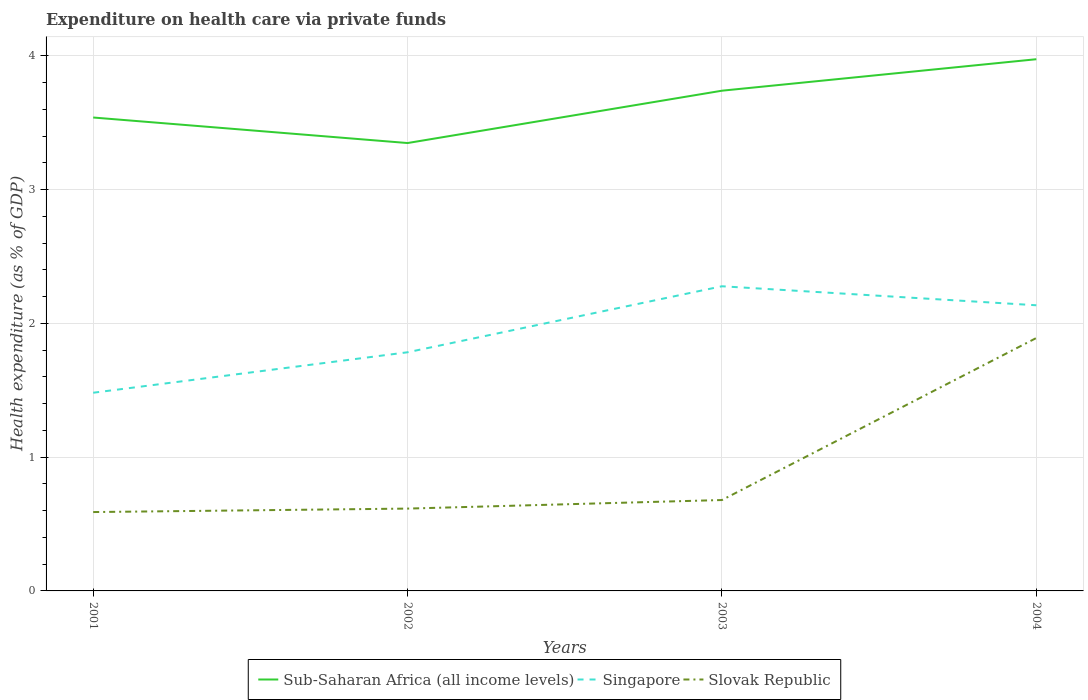How many different coloured lines are there?
Offer a very short reply. 3. Is the number of lines equal to the number of legend labels?
Offer a very short reply. Yes. Across all years, what is the maximum expenditure made on health care in Singapore?
Your answer should be very brief. 1.48. What is the total expenditure made on health care in Slovak Republic in the graph?
Your answer should be compact. -0.03. What is the difference between the highest and the second highest expenditure made on health care in Sub-Saharan Africa (all income levels)?
Provide a succinct answer. 0.63. How many lines are there?
Make the answer very short. 3. How many years are there in the graph?
Give a very brief answer. 4. What is the difference between two consecutive major ticks on the Y-axis?
Make the answer very short. 1. Are the values on the major ticks of Y-axis written in scientific E-notation?
Your response must be concise. No. Does the graph contain any zero values?
Your response must be concise. No. Does the graph contain grids?
Ensure brevity in your answer.  Yes. Where does the legend appear in the graph?
Your answer should be very brief. Bottom center. How are the legend labels stacked?
Ensure brevity in your answer.  Horizontal. What is the title of the graph?
Provide a short and direct response. Expenditure on health care via private funds. Does "Dominican Republic" appear as one of the legend labels in the graph?
Your answer should be very brief. No. What is the label or title of the Y-axis?
Provide a short and direct response. Health expenditure (as % of GDP). What is the Health expenditure (as % of GDP) of Sub-Saharan Africa (all income levels) in 2001?
Offer a terse response. 3.54. What is the Health expenditure (as % of GDP) in Singapore in 2001?
Give a very brief answer. 1.48. What is the Health expenditure (as % of GDP) of Slovak Republic in 2001?
Your answer should be compact. 0.59. What is the Health expenditure (as % of GDP) in Sub-Saharan Africa (all income levels) in 2002?
Offer a very short reply. 3.35. What is the Health expenditure (as % of GDP) of Singapore in 2002?
Ensure brevity in your answer.  1.78. What is the Health expenditure (as % of GDP) in Slovak Republic in 2002?
Give a very brief answer. 0.62. What is the Health expenditure (as % of GDP) in Sub-Saharan Africa (all income levels) in 2003?
Your response must be concise. 3.74. What is the Health expenditure (as % of GDP) of Singapore in 2003?
Your answer should be very brief. 2.28. What is the Health expenditure (as % of GDP) of Slovak Republic in 2003?
Keep it short and to the point. 0.68. What is the Health expenditure (as % of GDP) in Sub-Saharan Africa (all income levels) in 2004?
Give a very brief answer. 3.98. What is the Health expenditure (as % of GDP) in Singapore in 2004?
Your answer should be very brief. 2.14. What is the Health expenditure (as % of GDP) in Slovak Republic in 2004?
Make the answer very short. 1.89. Across all years, what is the maximum Health expenditure (as % of GDP) in Sub-Saharan Africa (all income levels)?
Offer a very short reply. 3.98. Across all years, what is the maximum Health expenditure (as % of GDP) of Singapore?
Provide a succinct answer. 2.28. Across all years, what is the maximum Health expenditure (as % of GDP) of Slovak Republic?
Make the answer very short. 1.89. Across all years, what is the minimum Health expenditure (as % of GDP) of Sub-Saharan Africa (all income levels)?
Your answer should be very brief. 3.35. Across all years, what is the minimum Health expenditure (as % of GDP) of Singapore?
Your response must be concise. 1.48. Across all years, what is the minimum Health expenditure (as % of GDP) of Slovak Republic?
Provide a short and direct response. 0.59. What is the total Health expenditure (as % of GDP) of Sub-Saharan Africa (all income levels) in the graph?
Ensure brevity in your answer.  14.6. What is the total Health expenditure (as % of GDP) of Singapore in the graph?
Offer a terse response. 7.68. What is the total Health expenditure (as % of GDP) in Slovak Republic in the graph?
Your answer should be very brief. 3.78. What is the difference between the Health expenditure (as % of GDP) in Sub-Saharan Africa (all income levels) in 2001 and that in 2002?
Make the answer very short. 0.19. What is the difference between the Health expenditure (as % of GDP) in Singapore in 2001 and that in 2002?
Make the answer very short. -0.3. What is the difference between the Health expenditure (as % of GDP) in Slovak Republic in 2001 and that in 2002?
Offer a very short reply. -0.03. What is the difference between the Health expenditure (as % of GDP) in Sub-Saharan Africa (all income levels) in 2001 and that in 2003?
Make the answer very short. -0.2. What is the difference between the Health expenditure (as % of GDP) of Singapore in 2001 and that in 2003?
Ensure brevity in your answer.  -0.8. What is the difference between the Health expenditure (as % of GDP) of Slovak Republic in 2001 and that in 2003?
Your answer should be very brief. -0.09. What is the difference between the Health expenditure (as % of GDP) of Sub-Saharan Africa (all income levels) in 2001 and that in 2004?
Your answer should be very brief. -0.44. What is the difference between the Health expenditure (as % of GDP) of Singapore in 2001 and that in 2004?
Provide a short and direct response. -0.65. What is the difference between the Health expenditure (as % of GDP) in Slovak Republic in 2001 and that in 2004?
Your response must be concise. -1.3. What is the difference between the Health expenditure (as % of GDP) of Sub-Saharan Africa (all income levels) in 2002 and that in 2003?
Keep it short and to the point. -0.39. What is the difference between the Health expenditure (as % of GDP) of Singapore in 2002 and that in 2003?
Provide a short and direct response. -0.49. What is the difference between the Health expenditure (as % of GDP) in Slovak Republic in 2002 and that in 2003?
Your answer should be very brief. -0.06. What is the difference between the Health expenditure (as % of GDP) in Sub-Saharan Africa (all income levels) in 2002 and that in 2004?
Ensure brevity in your answer.  -0.63. What is the difference between the Health expenditure (as % of GDP) in Singapore in 2002 and that in 2004?
Give a very brief answer. -0.35. What is the difference between the Health expenditure (as % of GDP) in Slovak Republic in 2002 and that in 2004?
Provide a succinct answer. -1.28. What is the difference between the Health expenditure (as % of GDP) of Sub-Saharan Africa (all income levels) in 2003 and that in 2004?
Offer a terse response. -0.24. What is the difference between the Health expenditure (as % of GDP) of Singapore in 2003 and that in 2004?
Give a very brief answer. 0.14. What is the difference between the Health expenditure (as % of GDP) of Slovak Republic in 2003 and that in 2004?
Keep it short and to the point. -1.21. What is the difference between the Health expenditure (as % of GDP) in Sub-Saharan Africa (all income levels) in 2001 and the Health expenditure (as % of GDP) in Singapore in 2002?
Your answer should be compact. 1.76. What is the difference between the Health expenditure (as % of GDP) in Sub-Saharan Africa (all income levels) in 2001 and the Health expenditure (as % of GDP) in Slovak Republic in 2002?
Your answer should be compact. 2.92. What is the difference between the Health expenditure (as % of GDP) of Singapore in 2001 and the Health expenditure (as % of GDP) of Slovak Republic in 2002?
Ensure brevity in your answer.  0.87. What is the difference between the Health expenditure (as % of GDP) of Sub-Saharan Africa (all income levels) in 2001 and the Health expenditure (as % of GDP) of Singapore in 2003?
Make the answer very short. 1.26. What is the difference between the Health expenditure (as % of GDP) of Sub-Saharan Africa (all income levels) in 2001 and the Health expenditure (as % of GDP) of Slovak Republic in 2003?
Your answer should be very brief. 2.86. What is the difference between the Health expenditure (as % of GDP) in Singapore in 2001 and the Health expenditure (as % of GDP) in Slovak Republic in 2003?
Provide a succinct answer. 0.8. What is the difference between the Health expenditure (as % of GDP) of Sub-Saharan Africa (all income levels) in 2001 and the Health expenditure (as % of GDP) of Singapore in 2004?
Make the answer very short. 1.4. What is the difference between the Health expenditure (as % of GDP) of Sub-Saharan Africa (all income levels) in 2001 and the Health expenditure (as % of GDP) of Slovak Republic in 2004?
Your answer should be very brief. 1.65. What is the difference between the Health expenditure (as % of GDP) in Singapore in 2001 and the Health expenditure (as % of GDP) in Slovak Republic in 2004?
Your response must be concise. -0.41. What is the difference between the Health expenditure (as % of GDP) in Sub-Saharan Africa (all income levels) in 2002 and the Health expenditure (as % of GDP) in Singapore in 2003?
Your answer should be very brief. 1.07. What is the difference between the Health expenditure (as % of GDP) of Sub-Saharan Africa (all income levels) in 2002 and the Health expenditure (as % of GDP) of Slovak Republic in 2003?
Keep it short and to the point. 2.67. What is the difference between the Health expenditure (as % of GDP) of Singapore in 2002 and the Health expenditure (as % of GDP) of Slovak Republic in 2003?
Offer a very short reply. 1.1. What is the difference between the Health expenditure (as % of GDP) in Sub-Saharan Africa (all income levels) in 2002 and the Health expenditure (as % of GDP) in Singapore in 2004?
Your answer should be very brief. 1.21. What is the difference between the Health expenditure (as % of GDP) in Sub-Saharan Africa (all income levels) in 2002 and the Health expenditure (as % of GDP) in Slovak Republic in 2004?
Make the answer very short. 1.46. What is the difference between the Health expenditure (as % of GDP) in Singapore in 2002 and the Health expenditure (as % of GDP) in Slovak Republic in 2004?
Make the answer very short. -0.11. What is the difference between the Health expenditure (as % of GDP) in Sub-Saharan Africa (all income levels) in 2003 and the Health expenditure (as % of GDP) in Singapore in 2004?
Ensure brevity in your answer.  1.6. What is the difference between the Health expenditure (as % of GDP) in Sub-Saharan Africa (all income levels) in 2003 and the Health expenditure (as % of GDP) in Slovak Republic in 2004?
Ensure brevity in your answer.  1.85. What is the difference between the Health expenditure (as % of GDP) in Singapore in 2003 and the Health expenditure (as % of GDP) in Slovak Republic in 2004?
Your answer should be compact. 0.39. What is the average Health expenditure (as % of GDP) in Sub-Saharan Africa (all income levels) per year?
Make the answer very short. 3.65. What is the average Health expenditure (as % of GDP) of Singapore per year?
Your answer should be very brief. 1.92. What is the average Health expenditure (as % of GDP) of Slovak Republic per year?
Provide a short and direct response. 0.94. In the year 2001, what is the difference between the Health expenditure (as % of GDP) in Sub-Saharan Africa (all income levels) and Health expenditure (as % of GDP) in Singapore?
Keep it short and to the point. 2.06. In the year 2001, what is the difference between the Health expenditure (as % of GDP) in Sub-Saharan Africa (all income levels) and Health expenditure (as % of GDP) in Slovak Republic?
Keep it short and to the point. 2.95. In the year 2001, what is the difference between the Health expenditure (as % of GDP) in Singapore and Health expenditure (as % of GDP) in Slovak Republic?
Your answer should be very brief. 0.89. In the year 2002, what is the difference between the Health expenditure (as % of GDP) of Sub-Saharan Africa (all income levels) and Health expenditure (as % of GDP) of Singapore?
Your answer should be very brief. 1.56. In the year 2002, what is the difference between the Health expenditure (as % of GDP) of Sub-Saharan Africa (all income levels) and Health expenditure (as % of GDP) of Slovak Republic?
Offer a terse response. 2.73. In the year 2002, what is the difference between the Health expenditure (as % of GDP) of Singapore and Health expenditure (as % of GDP) of Slovak Republic?
Make the answer very short. 1.17. In the year 2003, what is the difference between the Health expenditure (as % of GDP) of Sub-Saharan Africa (all income levels) and Health expenditure (as % of GDP) of Singapore?
Your answer should be compact. 1.46. In the year 2003, what is the difference between the Health expenditure (as % of GDP) in Sub-Saharan Africa (all income levels) and Health expenditure (as % of GDP) in Slovak Republic?
Your response must be concise. 3.06. In the year 2003, what is the difference between the Health expenditure (as % of GDP) in Singapore and Health expenditure (as % of GDP) in Slovak Republic?
Your answer should be compact. 1.6. In the year 2004, what is the difference between the Health expenditure (as % of GDP) in Sub-Saharan Africa (all income levels) and Health expenditure (as % of GDP) in Singapore?
Make the answer very short. 1.84. In the year 2004, what is the difference between the Health expenditure (as % of GDP) of Sub-Saharan Africa (all income levels) and Health expenditure (as % of GDP) of Slovak Republic?
Keep it short and to the point. 2.08. In the year 2004, what is the difference between the Health expenditure (as % of GDP) of Singapore and Health expenditure (as % of GDP) of Slovak Republic?
Offer a very short reply. 0.24. What is the ratio of the Health expenditure (as % of GDP) in Sub-Saharan Africa (all income levels) in 2001 to that in 2002?
Offer a terse response. 1.06. What is the ratio of the Health expenditure (as % of GDP) of Singapore in 2001 to that in 2002?
Provide a succinct answer. 0.83. What is the ratio of the Health expenditure (as % of GDP) in Slovak Republic in 2001 to that in 2002?
Keep it short and to the point. 0.96. What is the ratio of the Health expenditure (as % of GDP) of Sub-Saharan Africa (all income levels) in 2001 to that in 2003?
Keep it short and to the point. 0.95. What is the ratio of the Health expenditure (as % of GDP) of Singapore in 2001 to that in 2003?
Keep it short and to the point. 0.65. What is the ratio of the Health expenditure (as % of GDP) of Slovak Republic in 2001 to that in 2003?
Give a very brief answer. 0.87. What is the ratio of the Health expenditure (as % of GDP) of Sub-Saharan Africa (all income levels) in 2001 to that in 2004?
Provide a short and direct response. 0.89. What is the ratio of the Health expenditure (as % of GDP) of Singapore in 2001 to that in 2004?
Your answer should be compact. 0.69. What is the ratio of the Health expenditure (as % of GDP) in Slovak Republic in 2001 to that in 2004?
Provide a succinct answer. 0.31. What is the ratio of the Health expenditure (as % of GDP) of Sub-Saharan Africa (all income levels) in 2002 to that in 2003?
Keep it short and to the point. 0.9. What is the ratio of the Health expenditure (as % of GDP) of Singapore in 2002 to that in 2003?
Your response must be concise. 0.78. What is the ratio of the Health expenditure (as % of GDP) in Slovak Republic in 2002 to that in 2003?
Provide a short and direct response. 0.91. What is the ratio of the Health expenditure (as % of GDP) of Sub-Saharan Africa (all income levels) in 2002 to that in 2004?
Offer a very short reply. 0.84. What is the ratio of the Health expenditure (as % of GDP) of Singapore in 2002 to that in 2004?
Offer a terse response. 0.84. What is the ratio of the Health expenditure (as % of GDP) of Slovak Republic in 2002 to that in 2004?
Give a very brief answer. 0.33. What is the ratio of the Health expenditure (as % of GDP) of Sub-Saharan Africa (all income levels) in 2003 to that in 2004?
Make the answer very short. 0.94. What is the ratio of the Health expenditure (as % of GDP) of Singapore in 2003 to that in 2004?
Your answer should be very brief. 1.07. What is the ratio of the Health expenditure (as % of GDP) of Slovak Republic in 2003 to that in 2004?
Ensure brevity in your answer.  0.36. What is the difference between the highest and the second highest Health expenditure (as % of GDP) in Sub-Saharan Africa (all income levels)?
Provide a succinct answer. 0.24. What is the difference between the highest and the second highest Health expenditure (as % of GDP) of Singapore?
Offer a very short reply. 0.14. What is the difference between the highest and the second highest Health expenditure (as % of GDP) of Slovak Republic?
Offer a terse response. 1.21. What is the difference between the highest and the lowest Health expenditure (as % of GDP) in Sub-Saharan Africa (all income levels)?
Ensure brevity in your answer.  0.63. What is the difference between the highest and the lowest Health expenditure (as % of GDP) of Singapore?
Your response must be concise. 0.8. What is the difference between the highest and the lowest Health expenditure (as % of GDP) of Slovak Republic?
Give a very brief answer. 1.3. 